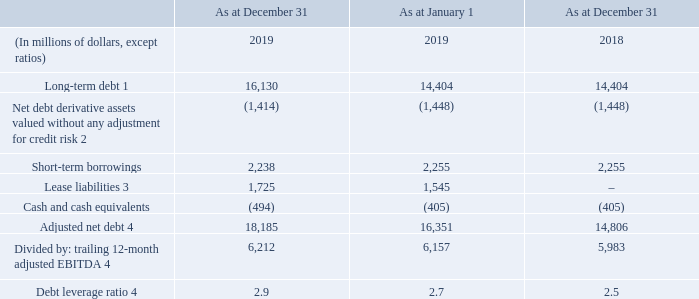ADJUSTED NET DEBT AND DEBT LEVERAGE RATIO
We use adjusted net debt and debt leverage ratio to conduct valuation-related analysis and make capital structure-related decisions. Adjusted net debt includes long-term debt, net debt derivative assets or liabilities, short-term borrowings, and cash and cash equivalents.
1 Includes current and long-term portion of long-term debt before deferred transaction costs and discounts. See “Reconciliation of adjusted net debt” in “Non-GAAP Measures and Related Performance Measures” for the calculation of this amount. 2 For purposes of calculating adjusted net debt and debt leverage ratio, we believe including debt derivatives valued without adjustment for credit risk is commonly used to evaluate debt leverage and for market valuation and transactional purposes.
3 See “Accounting Policies” for more information. 4 Adjusted net debt and adjusted EBITDA are non-GAAP measures and should not be considered substitutes or alternatives for GAAP measures. These are not defined terms under IFRS and do not have standard meanings, so may not be a reliable way to compare us to other companies. See “Non-GAAP Measures and Related Performance Measures” for information about these measures, including how we calculate themand the debt leverage ratio inwhich they are used.
As a result of our adoption of IFRS 16 effective January 1, 2019, we
have modified our definition of adjusted net debt such that it now includes the total of “current portion of lease liabilities” and “lease liabilities”. We believe adding total lease liabilities to adjusted net debt is appropriate as they reflect payments to which we are contractually committed and the related payments have been removed from our calculation of adjusted EBITDA due to the accounting change.
In addition, as at December 31, 2019, we held $1,831 million of
marketable securities in publicly traded companies (2018 – $1,051 million). Our adjusted net debt increased by $3,379 million from December 31, 2018 as a result of: • the inclusion of lease liabilities in the calculation, which had a balance of $1,725 million at year-end, as discussed above; and • a net increase in our outstanding long-term debt, in part due to the 600 MHz spectrum licences we acquired for $1,731 million this year; partially offset by • an increase in our net cash position.
See “Overview of Financial Position” for more information.
What is used for to conduct valuation-related analysis and make capital structure-related decisions? We use adjusted net debt and debt leverage ratio to conduct valuation-related analysis and make capital structure-related decisions. What is included in the adjusted net debt? Djusted net debt includes long-term debt, net debt derivative assets or liabilities, short-term borrowings, and cash and cash equivalents. Where is debt derivatives valued without adjustment for credit risk used for evaluation? For purposes of calculating adjusted net debt and debt leverage ratio, we believe including debt derivatives valued without adjustment for credit risk is commonly used to evaluate debt leverage and for market valuation and transactional purposes. What is the increase/ (decrease) in Long-term debt from December 31, 2018 to December 31, 2019?
Answer scale should be: million. 16,130-14,404
Answer: 1726. What is the increase/ (decrease) in Net debt derivative assets valued without any adjustment for credit risk from December 31, 2018 to December 31, 2019?
Answer scale should be: million. 1,414-1,448
Answer: -34. What is the increase/ (decrease) in Cash and cash equivalents from December 31, 2018 to December 31, 2019?
Answer scale should be: million. 494-405
Answer: 89. 